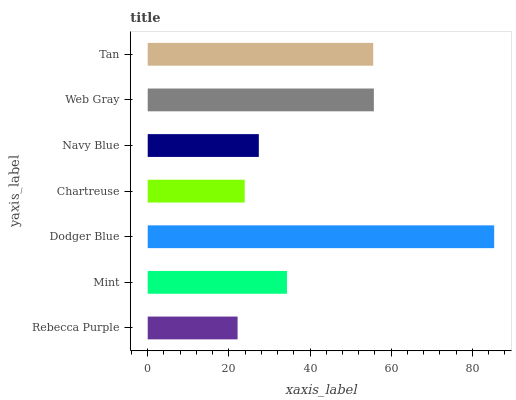Is Rebecca Purple the minimum?
Answer yes or no. Yes. Is Dodger Blue the maximum?
Answer yes or no. Yes. Is Mint the minimum?
Answer yes or no. No. Is Mint the maximum?
Answer yes or no. No. Is Mint greater than Rebecca Purple?
Answer yes or no. Yes. Is Rebecca Purple less than Mint?
Answer yes or no. Yes. Is Rebecca Purple greater than Mint?
Answer yes or no. No. Is Mint less than Rebecca Purple?
Answer yes or no. No. Is Mint the high median?
Answer yes or no. Yes. Is Mint the low median?
Answer yes or no. Yes. Is Web Gray the high median?
Answer yes or no. No. Is Tan the low median?
Answer yes or no. No. 